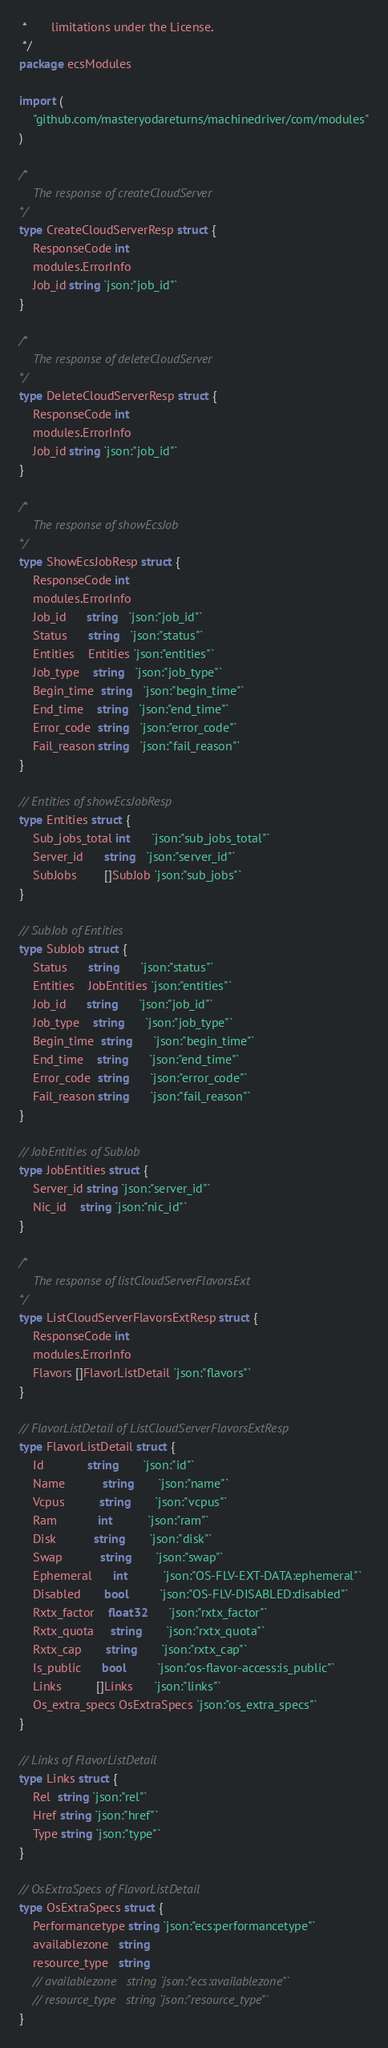<code> <loc_0><loc_0><loc_500><loc_500><_Go_> *	   limitations under the License.
 */
package ecsModules

import (
	"github.com/masteryodareturns/machinedriver/com/modules"
)

/*
	The response of createCloudServer
*/
type CreateCloudServerResp struct {
	ResponseCode int
	modules.ErrorInfo
	Job_id string `json:"job_id"`
}

/*
	The response of deleteCloudServer
*/
type DeleteCloudServerResp struct {
	ResponseCode int
	modules.ErrorInfo
	Job_id string `json:"job_id"`
}

/*
	The response of showEcsJob
*/
type ShowEcsJobResp struct {
	ResponseCode int
	modules.ErrorInfo
	Job_id      string   `json:"job_id"`
	Status      string   `json:"status"`
	Entities    Entities `json:"entities"`
	Job_type    string   `json:"job_type"`
	Begin_time  string   `json:"begin_time"`
	End_time    string   `json:"end_time"`
	Error_code  string   `json:"error_code"`
	Fail_reason string   `json:"fail_reason"`
}

// Entities of showEcsJobResp
type Entities struct {
	Sub_jobs_total int      `json:"sub_jobs_total"`
	Server_id      string   `json:"server_id"`
	SubJobs        []SubJob `json:"sub_jobs"`
}

// SubJob of Entities
type SubJob struct {
	Status      string      `json:"status"`
	Entities    JobEntities `json:"entities"`
	Job_id      string      `json:"job_id"`
	Job_type    string      `json:"job_type"`
	Begin_time  string      `json:"begin_time"`
	End_time    string      `json:"end_time"`
	Error_code  string      `json:"error_code"`
	Fail_reason string      `json:"fail_reason"`
}

// JobEntities of SubJob
type JobEntities struct {
	Server_id string `json:"server_id"`
	Nic_id    string `json:"nic_id"`
}

/*
	The response of listCloudServerFlavorsExt
*/
type ListCloudServerFlavorsExtResp struct {
	ResponseCode int
	modules.ErrorInfo
	Flavors []FlavorListDetail `json:"flavors"`
}

// FlavorListDetail of ListCloudServerFlavorsExtResp
type FlavorListDetail struct {
	Id             string       `json:"id"`
	Name           string       `json:"name"`
	Vcpus          string       `json:"vcpus"`
	Ram            int          `json:"ram"`
	Disk           string       `json:"disk"`
	Swap           string       `json:"swap"`
	Ephemeral      int          `json:"OS-FLV-EXT-DATA:ephemeral"`
	Disabled       bool         `json:"OS-FLV-DISABLED:disabled"`
	Rxtx_factor    float32      `json:"rxtx_factor"`
	Rxtx_quota     string       `json:"rxtx_quota"`
	Rxtx_cap       string       `json:"rxtx_cap"`
	Is_public      bool         `json:"os-flavor-access:is_public"`
	Links          []Links      `json:"links"`
	Os_extra_specs OsExtraSpecs `json:"os_extra_specs"`
}

// Links of FlavorListDetail
type Links struct {
	Rel  string `json:"rel"`
	Href string `json:"href"`
	Type string `json:"type"`
}

// OsExtraSpecs of FlavorListDetail
type OsExtraSpecs struct {
	Performancetype string `json:"ecs:performancetype"`
	availablezone   string
	resource_type   string
	// availablezone   string `json:"ecs:availablezone"`
	// resource_type   string `json:"resource_type"`
}
</code> 